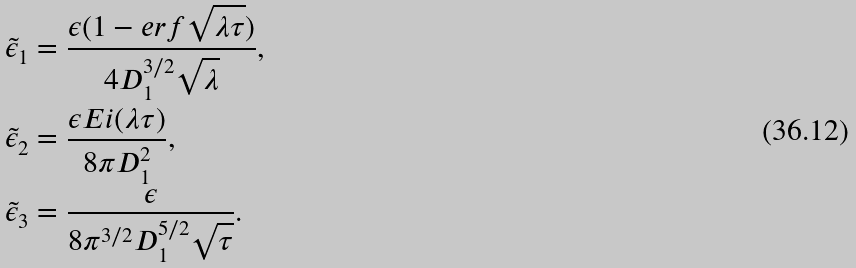<formula> <loc_0><loc_0><loc_500><loc_500>\tilde { \epsilon } _ { 1 } & = \frac { \epsilon ( 1 - e r f \sqrt { \lambda \tau } ) } { 4 D _ { 1 } ^ { 3 / 2 } \sqrt { \lambda } } , \\ \tilde { \epsilon } _ { 2 } & = \frac { \epsilon E i ( \lambda \tau ) } { 8 \pi D _ { 1 } ^ { 2 } } , \\ \tilde { \epsilon } _ { 3 } & = \frac { \epsilon } { 8 \pi ^ { 3 / 2 } D _ { 1 } ^ { 5 / 2 } \sqrt { \tau } } .</formula> 